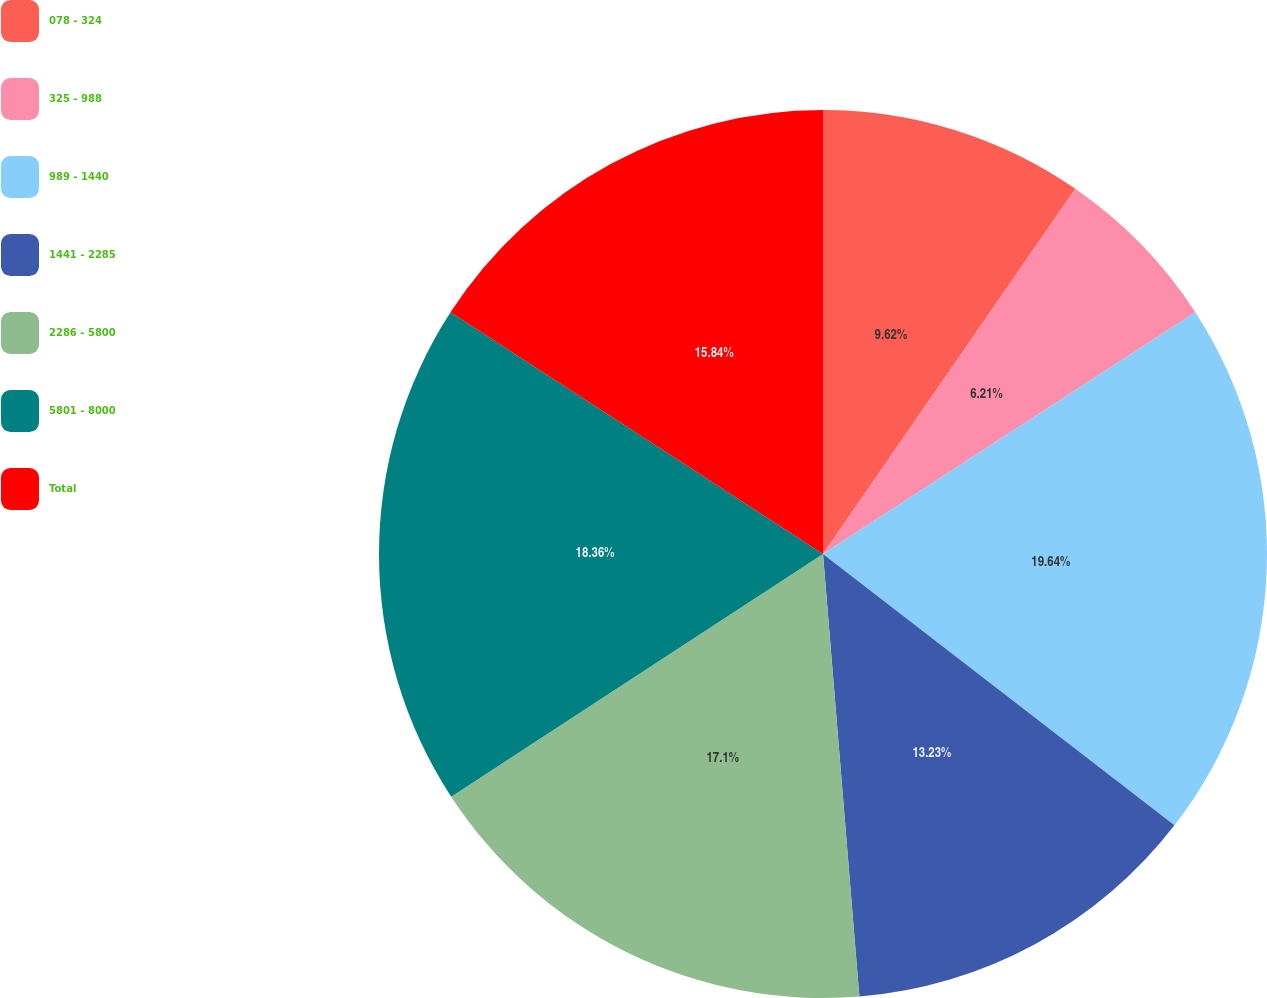<chart> <loc_0><loc_0><loc_500><loc_500><pie_chart><fcel>078 - 324<fcel>325 - 988<fcel>989 - 1440<fcel>1441 - 2285<fcel>2286 - 5800<fcel>5801 - 8000<fcel>Total<nl><fcel>9.62%<fcel>6.21%<fcel>19.63%<fcel>13.23%<fcel>17.1%<fcel>18.36%<fcel>15.84%<nl></chart> 